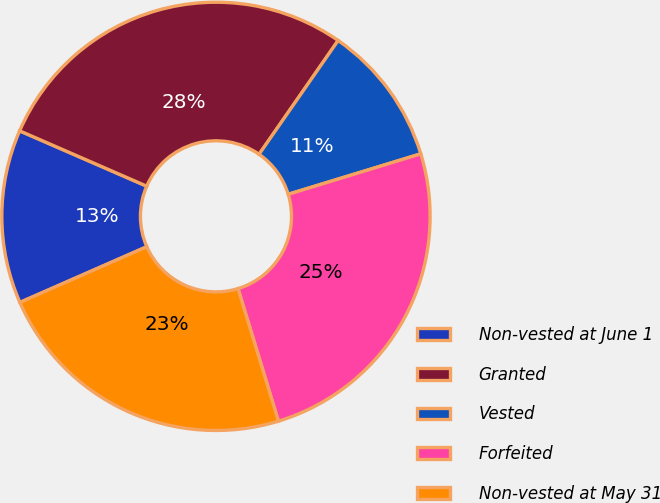Convert chart to OTSL. <chart><loc_0><loc_0><loc_500><loc_500><pie_chart><fcel>Non-vested at June 1<fcel>Granted<fcel>Vested<fcel>Forfeited<fcel>Non-vested at May 31<nl><fcel>13.12%<fcel>28.12%<fcel>10.62%<fcel>25.0%<fcel>23.12%<nl></chart> 